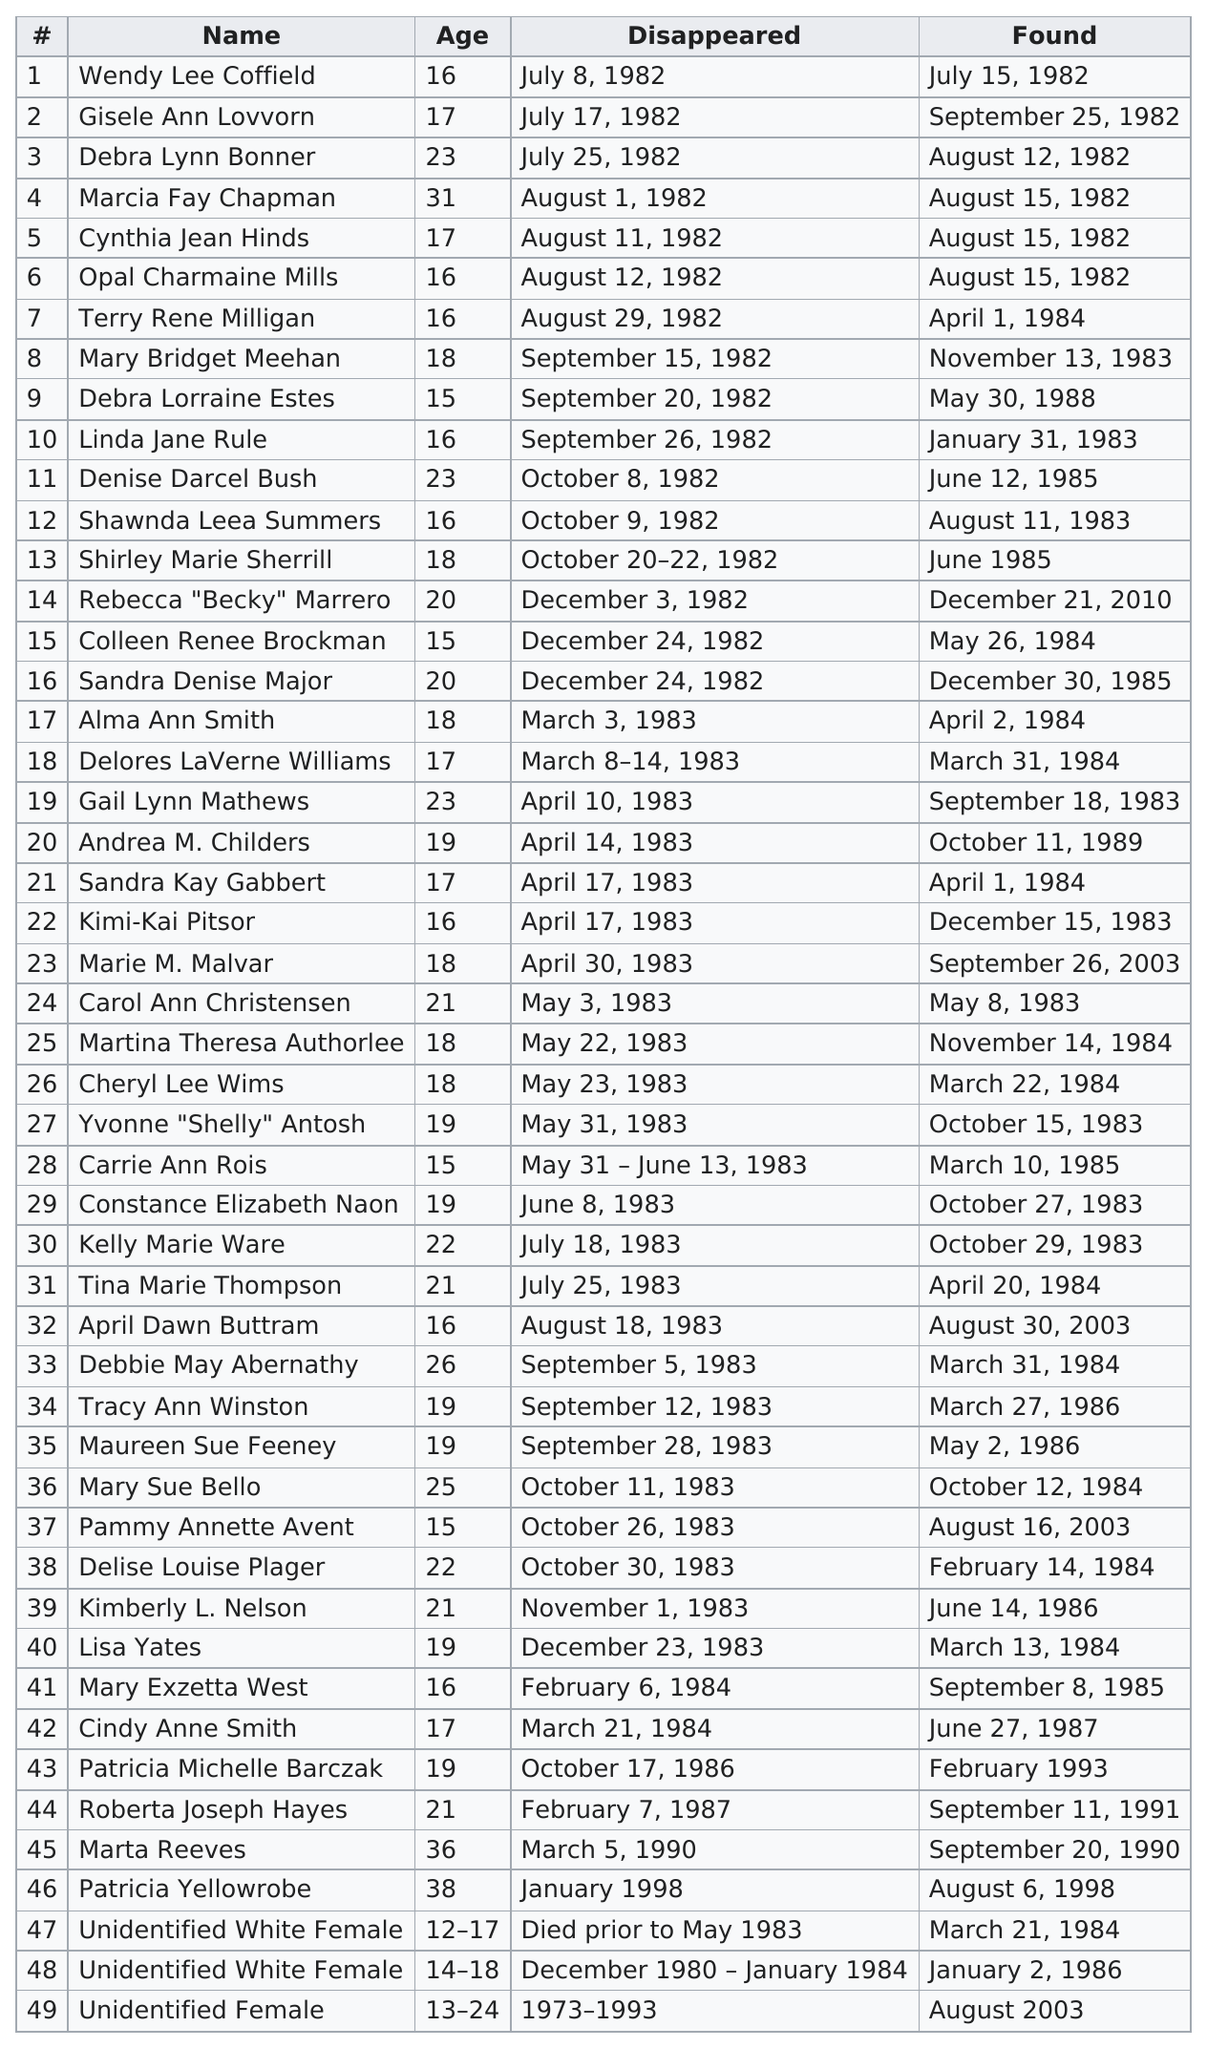Point out several critical features in this image. The oldest victim was Patricia Yellowrobe. Becky Marrero was the victim who was missing the longest. The youngest victim was an unidentified white female. 